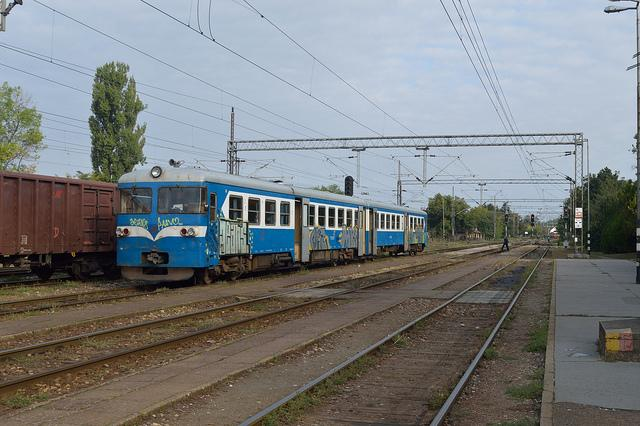What is the name of the painting on the outside of the blue train?

Choices:
A) fine art
B) acrylic
C) graffiti
D) oil graffiti 